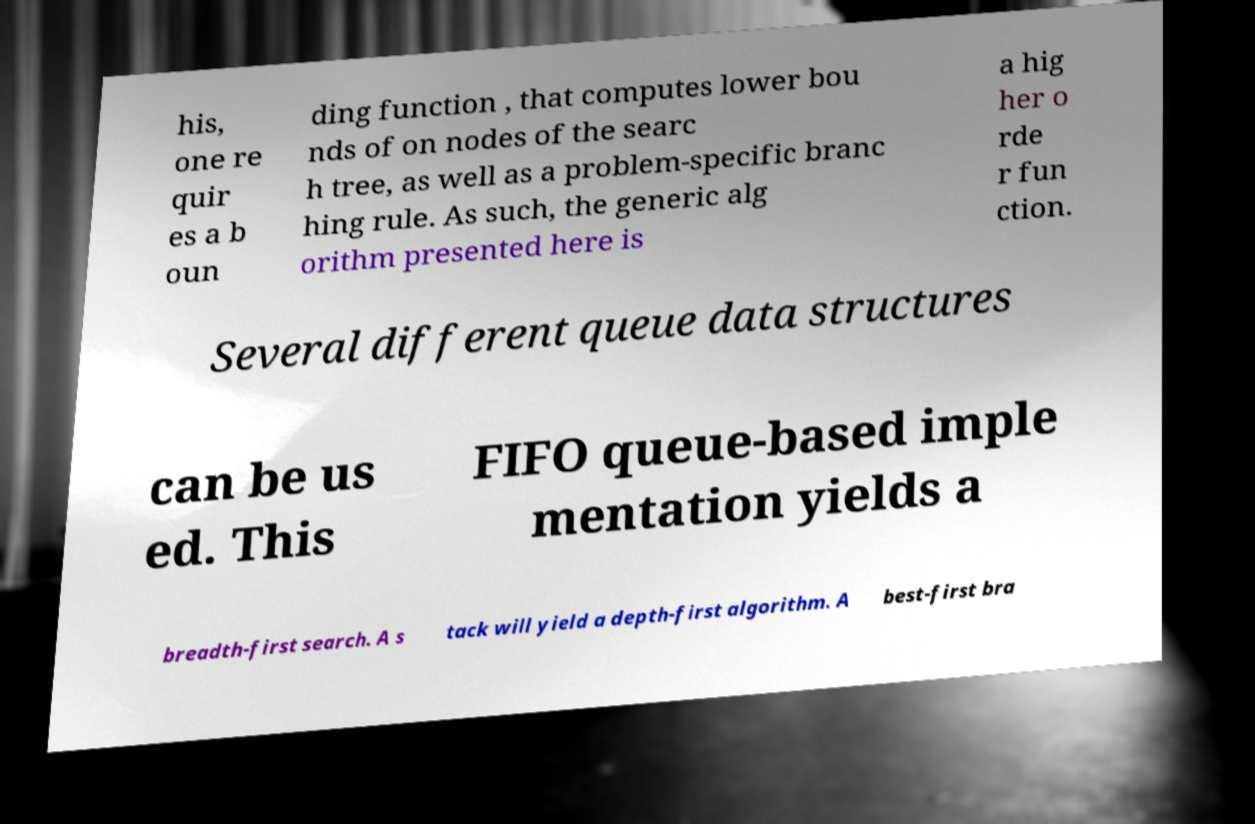Please read and relay the text visible in this image. What does it say? his, one re quir es a b oun ding function , that computes lower bou nds of on nodes of the searc h tree, as well as a problem-specific branc hing rule. As such, the generic alg orithm presented here is a hig her o rde r fun ction. Several different queue data structures can be us ed. This FIFO queue-based imple mentation yields a breadth-first search. A s tack will yield a depth-first algorithm. A best-first bra 